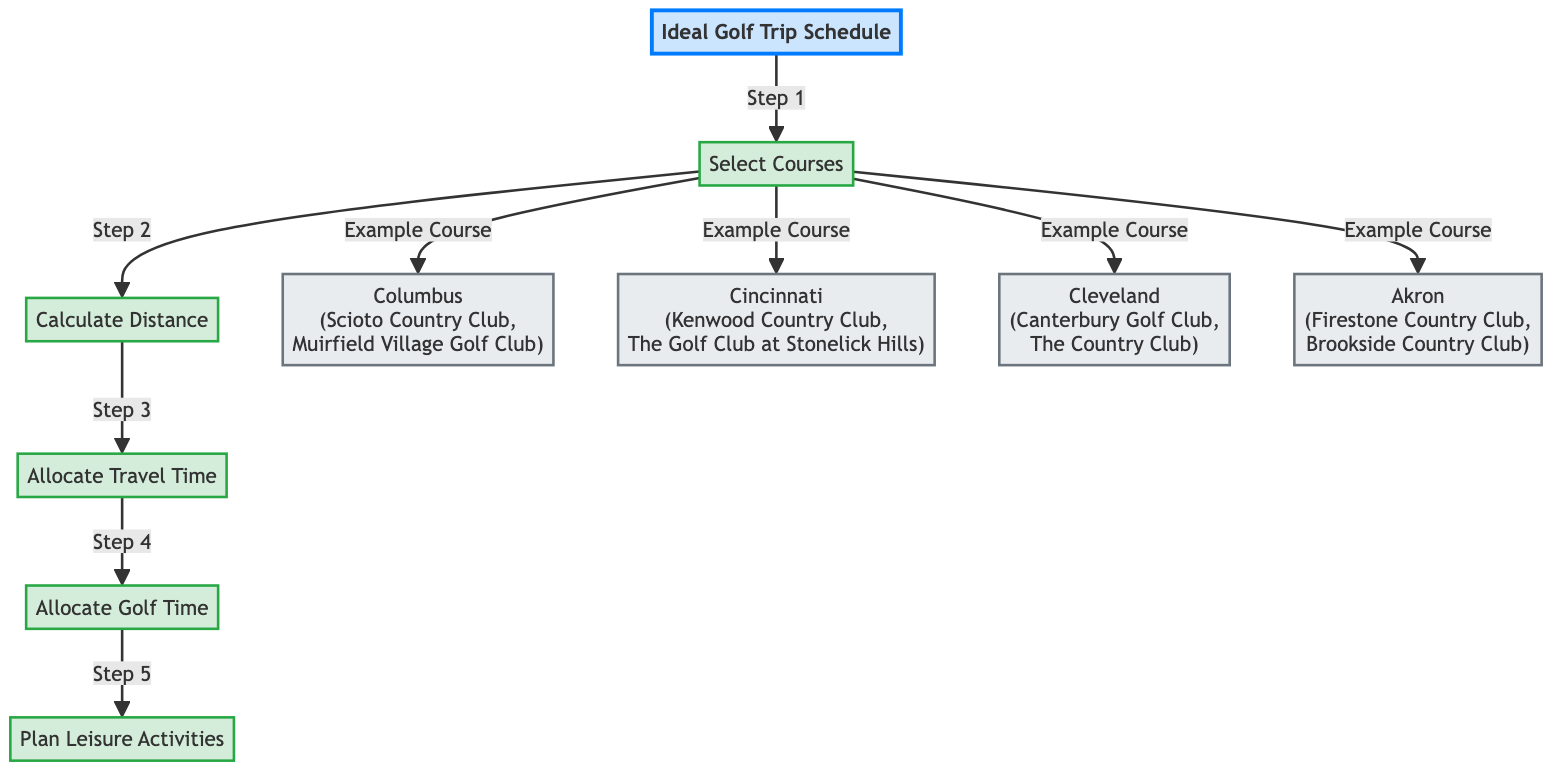What is the first step in the golf trip scheduling process? The first step in the diagram is labeled as "Step 1" and points to "Select Courses." This indicates that the initial action to be taken in the scheduling process is to choose the golf courses to visit.
Answer: Select Courses How many locations are included in the course selection? The diagram shows four specific locations under the "Select Courses" node: Columbus, Cincinnati, Cleveland, and Akron. By counting these locations, we see that there are four in total.
Answer: 4 What node follows "Calculate Distance" in the process? Following the "Calculate Distance" node, the arrow leads to "Allocate Travel Time." This indicates that once the distances are calculated, the next step is to determine the travel time required for the trip.
Answer: Allocate Travel Time Which location includes Scioto Country Club? In the diagram, Scioto Country Club is listed under the location of Columbus. Therefore, this location specifically includes that golf course as one of its examples.
Answer: Columbus What is the last step in the scheduling process? The diagram concludes with "Plan Leisure Activities" as the last step, which follows the allocation of golf time. This shows that the final consideration in scheduling is to arrange leisure activities.
Answer: Plan Leisure Activities How are travel time and golf time connected in the diagram? The diagram demonstrates a flow from "Allocate Travel Time" to "Allocate Golf Time," meaning that after travel time is allocated, the next focus is on scheduling the actual time for playing golf.
Answer: Allocate Golf Time What is the relationship between "Select Courses" and the specific locations? The relationship indicated in the diagram is a direct connection, where "Select Courses" branches out to showcase specific locations like Columbus, Cincinnati, Cleveland, and Akron, each being an example of potential golf courses selections.
Answer: Direct connection What is the sequence of steps shown in the diagram? The sequence of steps is shown as: 1. Select Courses, 2. Calculate Distance, 3. Allocate Travel Time, 4. Allocate Golf Time, and finally 5. Plan Leisure Activities. This represents the flow from beginning to end in scheduling the golf trip.
Answer: Select Courses, Calculate Distance, Allocate Travel Time, Allocate Golf Time, Plan Leisure Activities 